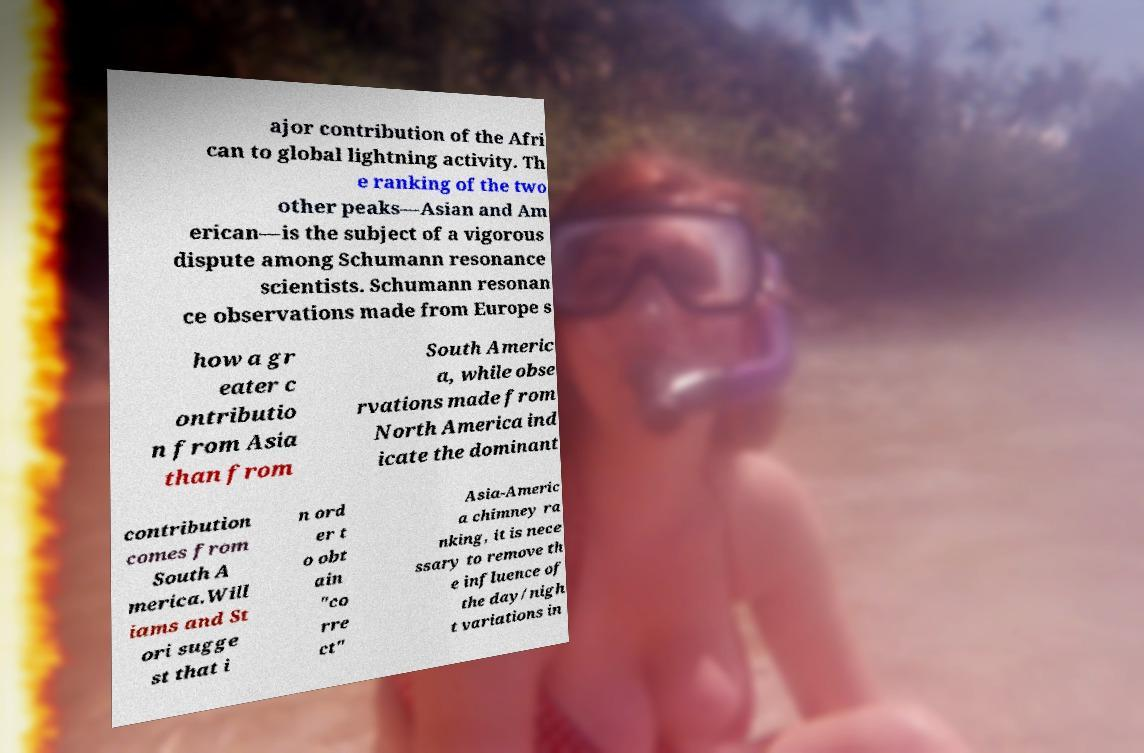There's text embedded in this image that I need extracted. Can you transcribe it verbatim? ajor contribution of the Afri can to global lightning activity. Th e ranking of the two other peaks—Asian and Am erican—is the subject of a vigorous dispute among Schumann resonance scientists. Schumann resonan ce observations made from Europe s how a gr eater c ontributio n from Asia than from South Americ a, while obse rvations made from North America ind icate the dominant contribution comes from South A merica.Will iams and St ori sugge st that i n ord er t o obt ain "co rre ct" Asia-Americ a chimney ra nking, it is nece ssary to remove th e influence of the day/nigh t variations in 